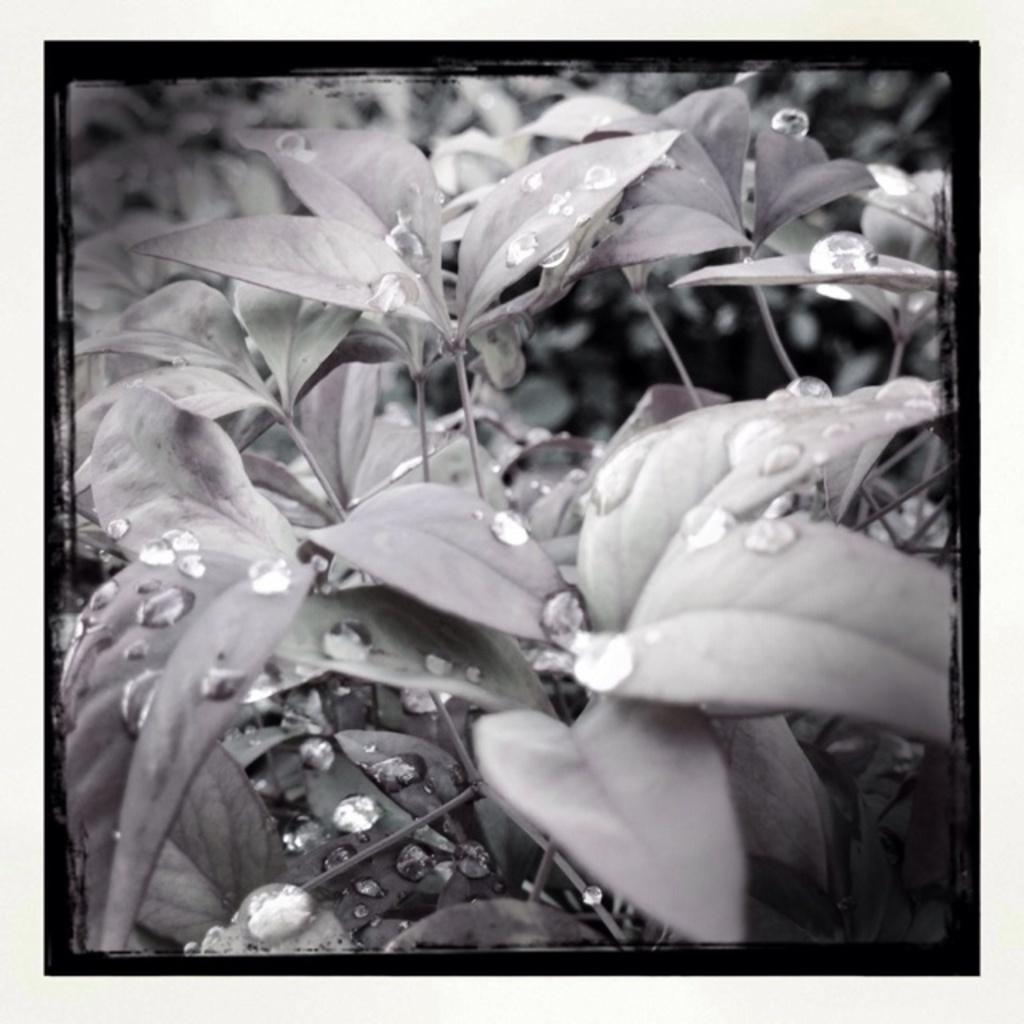What type of plant material is present in the image? There are leaves in the image. What else can be seen on the leaves in the image? There are water droplets on the leaves in the image. What supports the leaves in the image? There are stems in the image. How many geese are swimming in the water droplets in the image? There are no geese present in the image; it only features leaves, water droplets, and stems. What type of honey is dripping from the leaves in the image? There is no honey present in the image; it only features leaves, water droplets, and stems. 